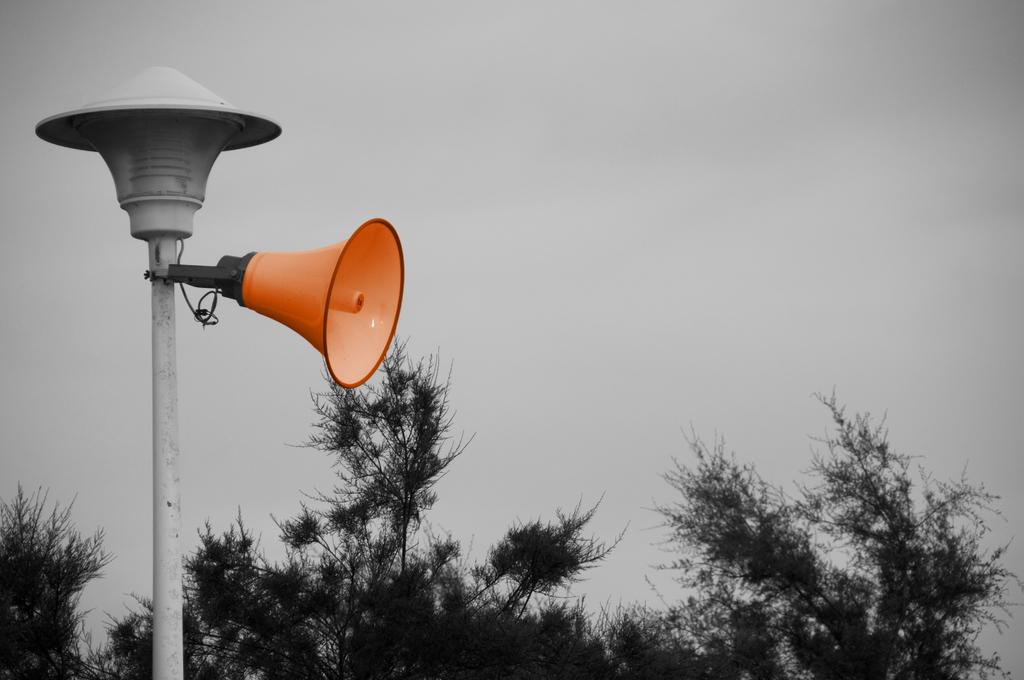What is located on the left side of the image? There is a pole on the left side of the image. What is attached to the pole? A speaker is attached to the pole. What type of vegetation can be seen at the bottom of the image? Trees are visible at the bottom of the image. What is visible in the background of the image? There is sky visible in the background of the image. Can you tell me how many boats are docked in the cave in the image? There are no boats or caves present in the image; it features a pole with a speaker, trees, and sky. 